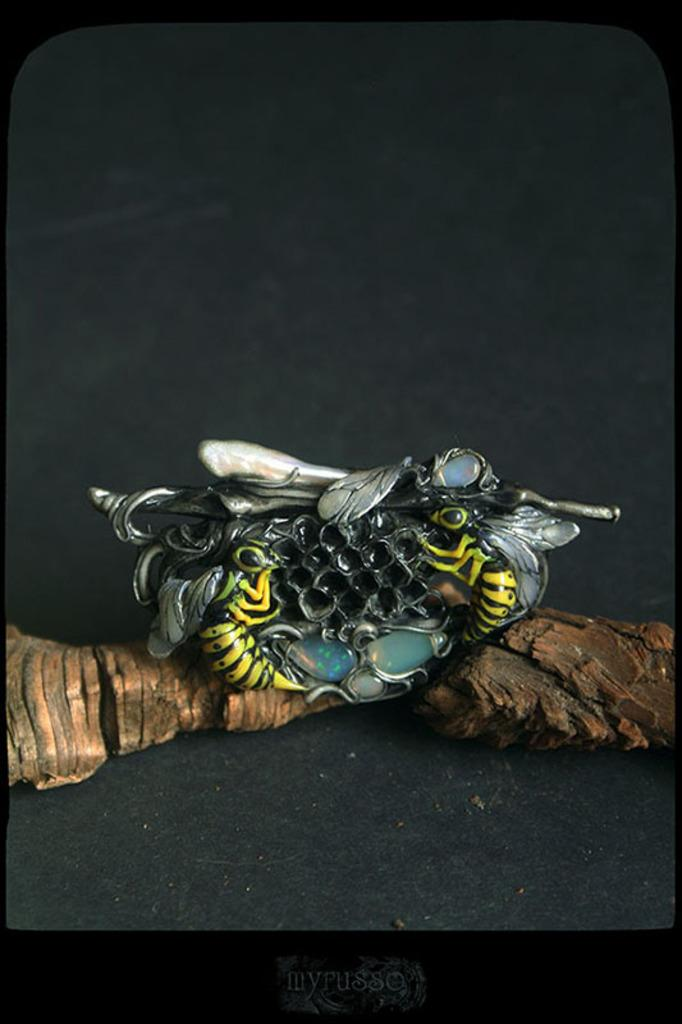What object is the main subject of the image? There is a key chain in the image. What design is featured on the key chain? The key chain has a design of honey bees. What is the color of the surface on which the key chain is placed? The key chain is placed on a black surface. Where is the library located in the image? There is no library present in the image. Can you tell me how many sinks are visible in the image? There are no sinks present in the image. 